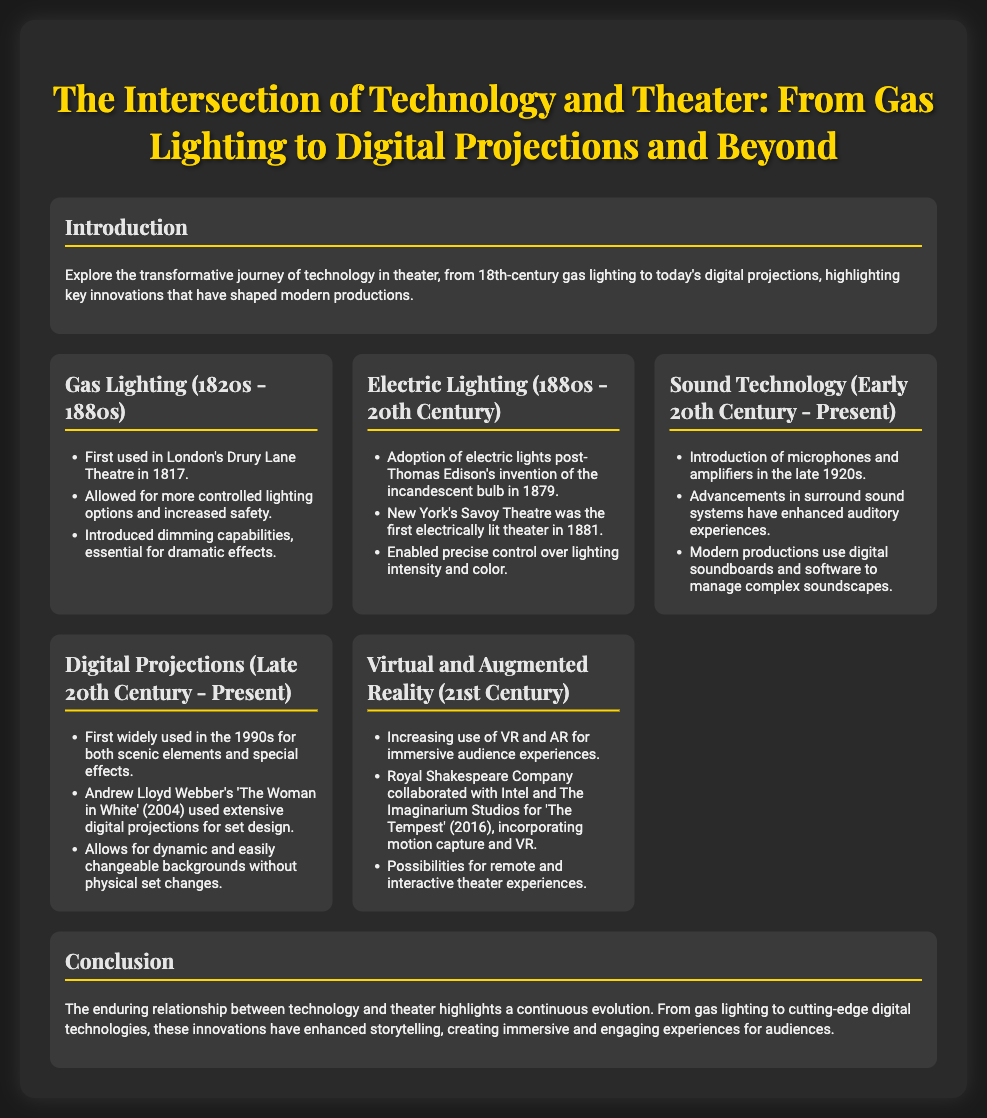What was the first theater to use gas lighting? The document states that London's Drury Lane Theatre first used gas lighting in 1817.
Answer: London's Drury Lane Theatre When did electric lighting become adopted in theaters? The transition to electric lighting began after Thomas Edison's invention of the incandescent bulb in 1879, according to the document.
Answer: 1880s What technology began to enhance auditory experiences in the late 1920s? The document mentions the introduction of microphones and amplifiers during this time.
Answer: Microphones and amplifiers Which musical extensively used digital projections for set design? The document references Andrew Lloyd Webber's 'The Woman in White' as a significant example.
Answer: The Woman in White What immersive technologies are highlighted for use in the 21st century? The presentation discusses the increasing use of virtual and augmented reality in theater.
Answer: Virtual and augmented reality How did gas lighting improve theater safety? The document indicates that gas lighting allowed for more controlled lighting options, enhancing safety.
Answer: Increased safety Which theater was the first electrically lit theater? The presentation notes that New York's Savoy Theatre was the first electrically lit theater in 1881.
Answer: Savoy Theatre What is a key impact of technology on storytelling in theater? The conclusion emphasizes that innovations enhance storytelling and create immersive experiences.
Answer: Immersive experiences 